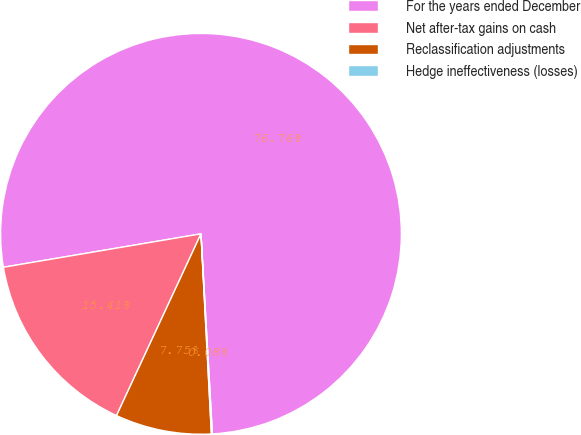Convert chart. <chart><loc_0><loc_0><loc_500><loc_500><pie_chart><fcel>For the years ended December<fcel>Net after-tax gains on cash<fcel>Reclassification adjustments<fcel>Hedge ineffectiveness (losses)<nl><fcel>76.76%<fcel>15.41%<fcel>7.75%<fcel>0.08%<nl></chart> 